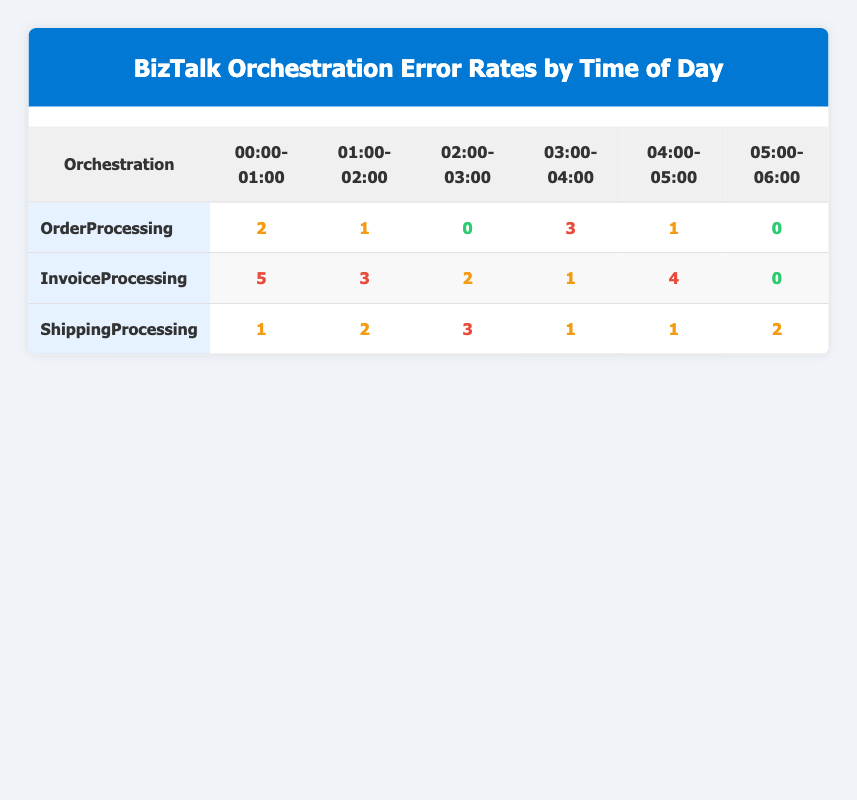What is the error count for the OrderProcessing orchestration at 03:00-04:00? In the table, we look for the OrderProcessing row under the column for the time 03:00-04:00. The error count listed there is 3.
Answer: 3 How many errors did the InvoiceProcessing orchestration have in total? To find the total errors for InvoiceProcessing, we sum all error counts across its time slots: 5 + 3 + 2 + 1 + 4 + 0 = 15.
Answer: 15 Is the error count for ShippingProcessing at 02:00-03:00 greater than 3? The ShippingProcessing orchestration shows an error count of 3 for the time slot 02:00-03:00. Since 3 is not greater than 3, the answer is no.
Answer: No What is the maximum error count across all orchestrations during the time interval 00:00-01:00? We can identify the error counts for each orchestration during 00:00-01:00: OrderProcessing has 2, InvoiceProcessing has 5, and ShippingProcessing has 1. The maximum from these values is 5.
Answer: 5 What is the average error count for the ShippingProcessing orchestration? The error counts for ShippingProcessing are 1, 2, 3, 1, 1, and 2. We sum these values: 1 + 2 + 3 + 1 + 1 + 2 = 10. There are 6 entries, so we calculate the average: 10/6 = 1.67.
Answer: 1.67 Did the InvoiceProcessing orchestration have more errors at 04:00-05:00 than the OrderProcessing orchestration at 02:00-03:00? InvoiceProcessing has 4 errors at 04:00-05:00, while OrderProcessing has 0 errors at 02:00-03:00. Since 4 is greater than 0, the answer is yes.
Answer: Yes What time of day saw the highest error count for any orchestration? Looking at the highest error counts for each orchestration: OrderProcessing had 3 at 03:00-04:00, InvoiceProcessing had 5 at 00:00-01:00, and ShippingProcessing had 3 at 02:00-03:00. The highest is 5 during 00:00-01:00 for InvoiceProcessing.
Answer: 00:00-01:00 Which orchestration has the least number of errors reported at 05:00-06:00? In the table for 05:00-06:00, OrderProcessing has 0 errors, InvoiceProcessing has 0 errors, and ShippingProcessing has 2 errors. Both OrderProcessing and InvoiceProcessing have the least number of errors with 0.
Answer: OrderProcessing and InvoiceProcessing How many time slots reported a total error count of 0 across all orchestrations? We check each orchestration's time slots: OrderProcessing has 02:00-03:00 and 05:00-06:00; InvoiceProcessing has 05:00-06:00; ShippingProcessing has no time slots with 0 errors. Therefore, there are 3 unique time slots with a total count of 0 across all orchestrations.
Answer: 3 